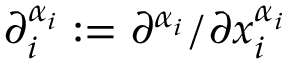<formula> <loc_0><loc_0><loc_500><loc_500>\partial _ { i } ^ { \alpha _ { i } } \colon = \partial ^ { \alpha _ { i } } / \partial x _ { i } ^ { \alpha _ { i } }</formula> 